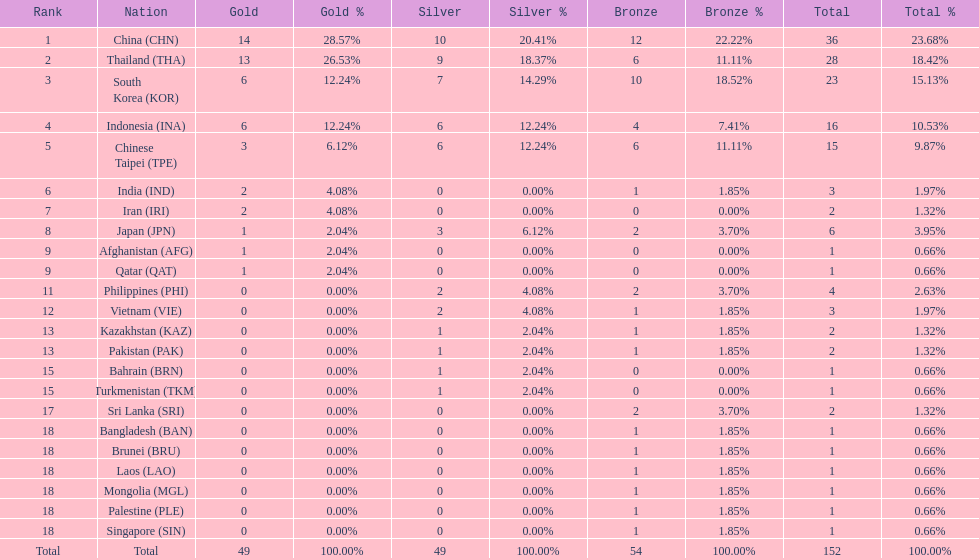How many more medals did india earn compared to pakistan? 1. 